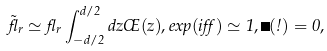Convert formula to latex. <formula><loc_0><loc_0><loc_500><loc_500>\tilde { \gamma } _ { r } \simeq \gamma _ { r } \int _ { - d / 2 } ^ { d / 2 } d z \phi ( z ) , e x p ( i \alpha ) \simeq 1 , \Delta ( \omega ) = 0 ,</formula> 